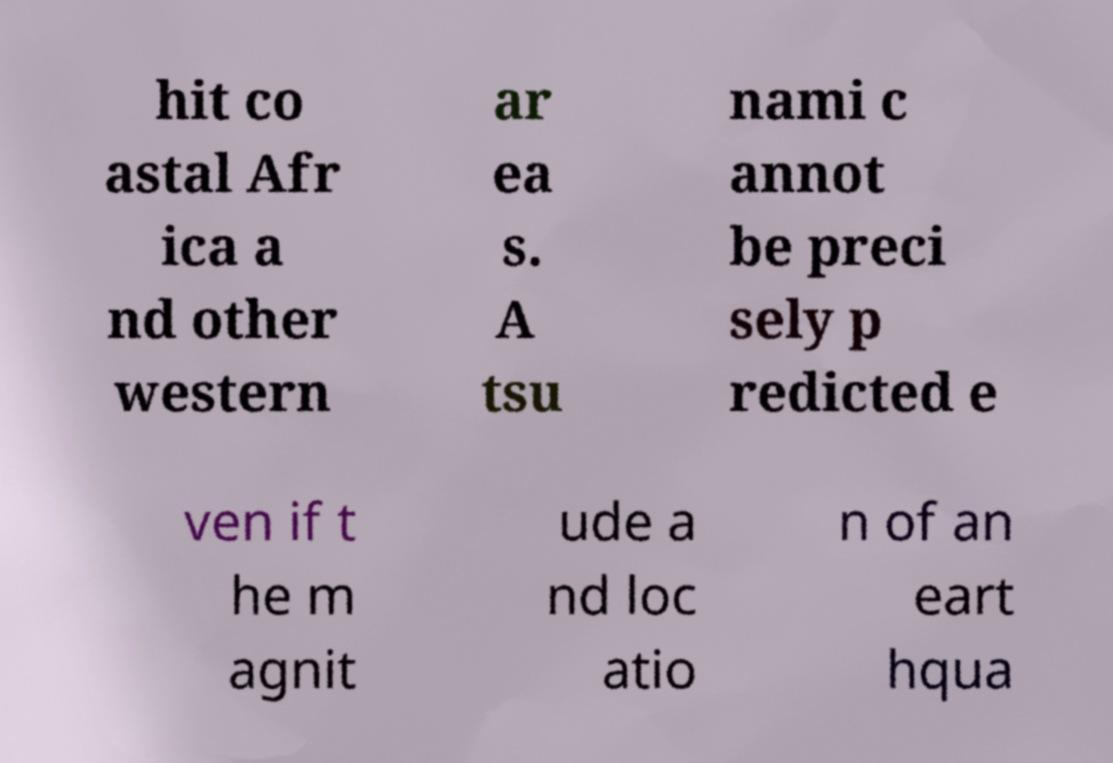I need the written content from this picture converted into text. Can you do that? hit co astal Afr ica a nd other western ar ea s. A tsu nami c annot be preci sely p redicted e ven if t he m agnit ude a nd loc atio n of an eart hqua 